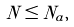Convert formula to latex. <formula><loc_0><loc_0><loc_500><loc_500>N \leq N _ { a } ,</formula> 